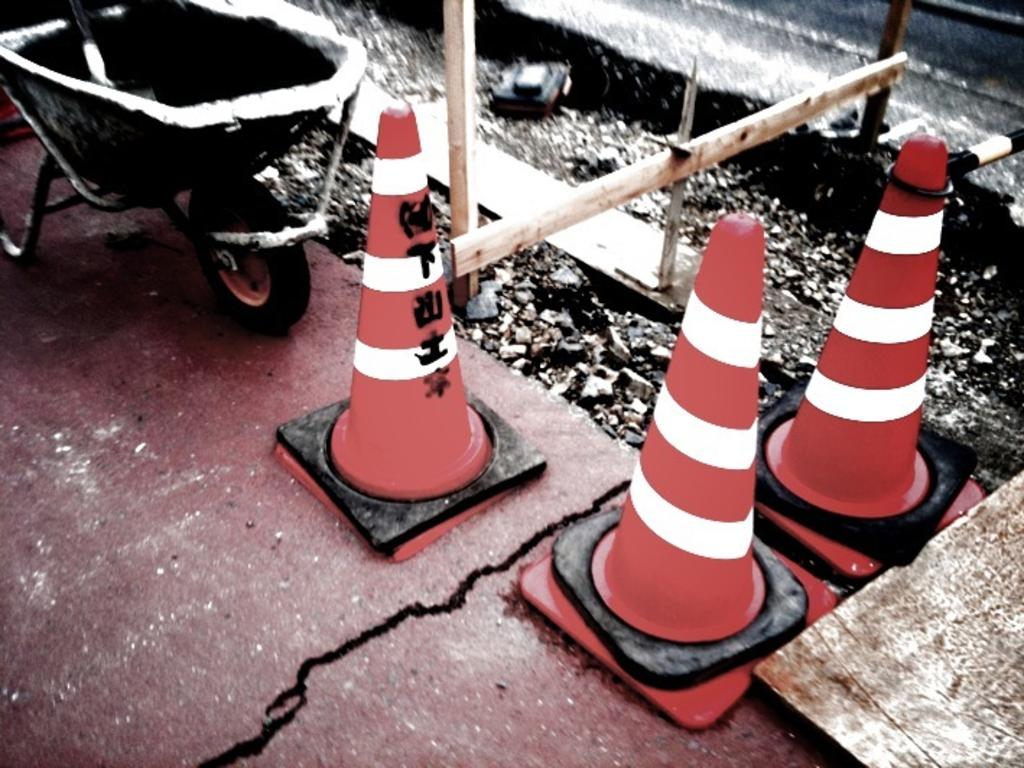What objects can be seen on the ground in the image? There are traffic cones and wooden poles on the ground in the image. Are there any other objects visible on the ground? Yes, there are other objects on the ground in the image. What organization is responsible for the title of the image? There is no title mentioned in the image, and therefore no organization is associated with it. 